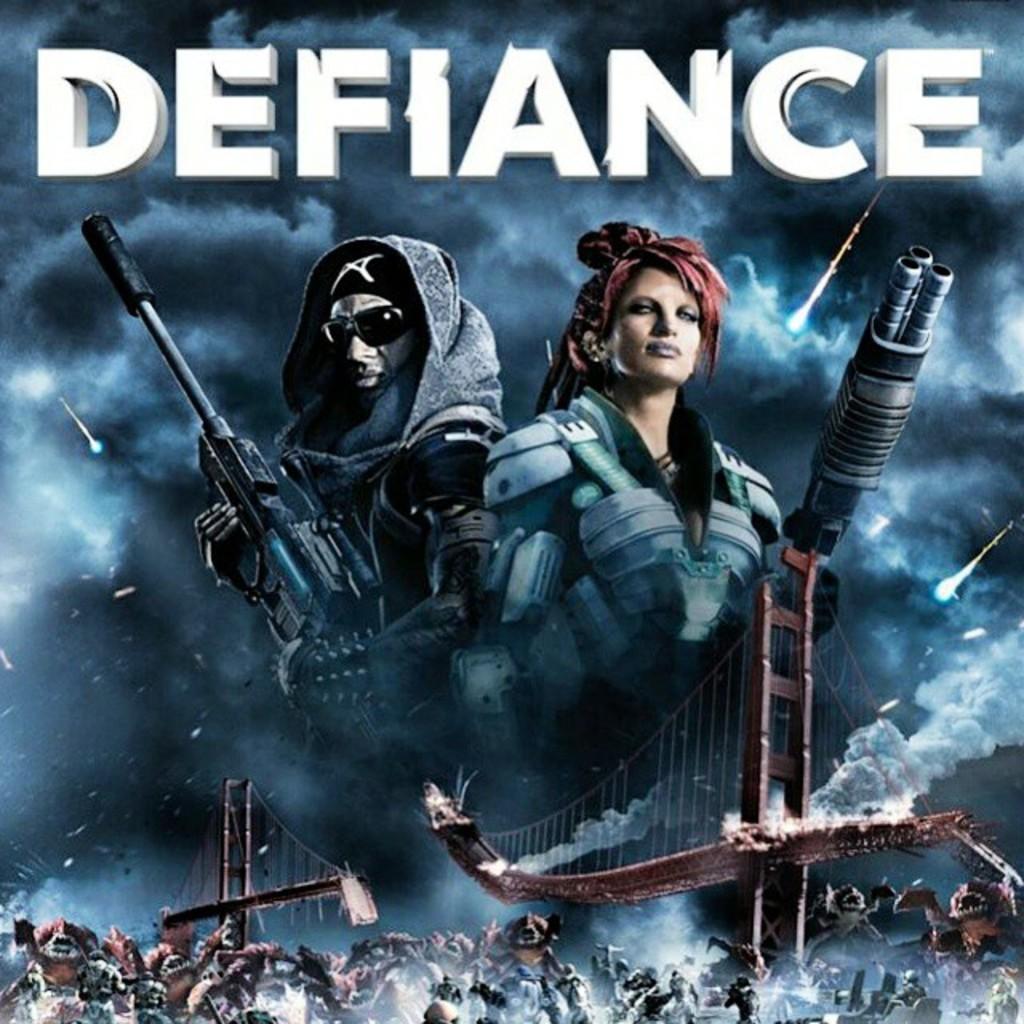What is the name of this game?
Your response must be concise. Defiance. How many letters is the only word on this ad/poster?
Your answer should be compact. 8. 